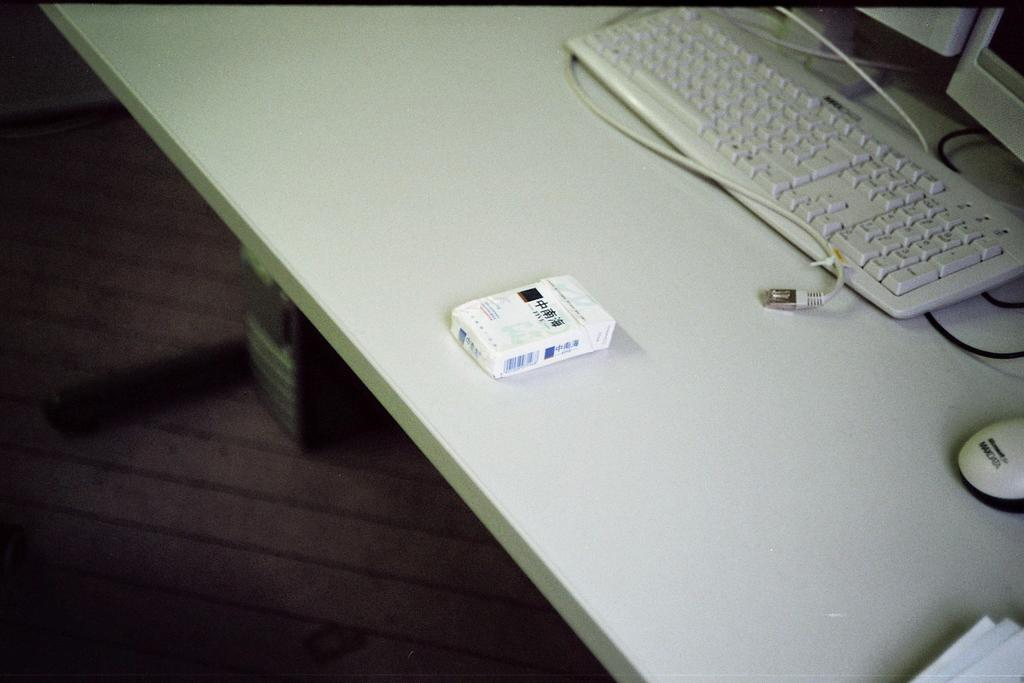<image>
Give a short and clear explanation of the subsequent image. A keyboard that has a 1 thru 9 number pad sits on a desk. 